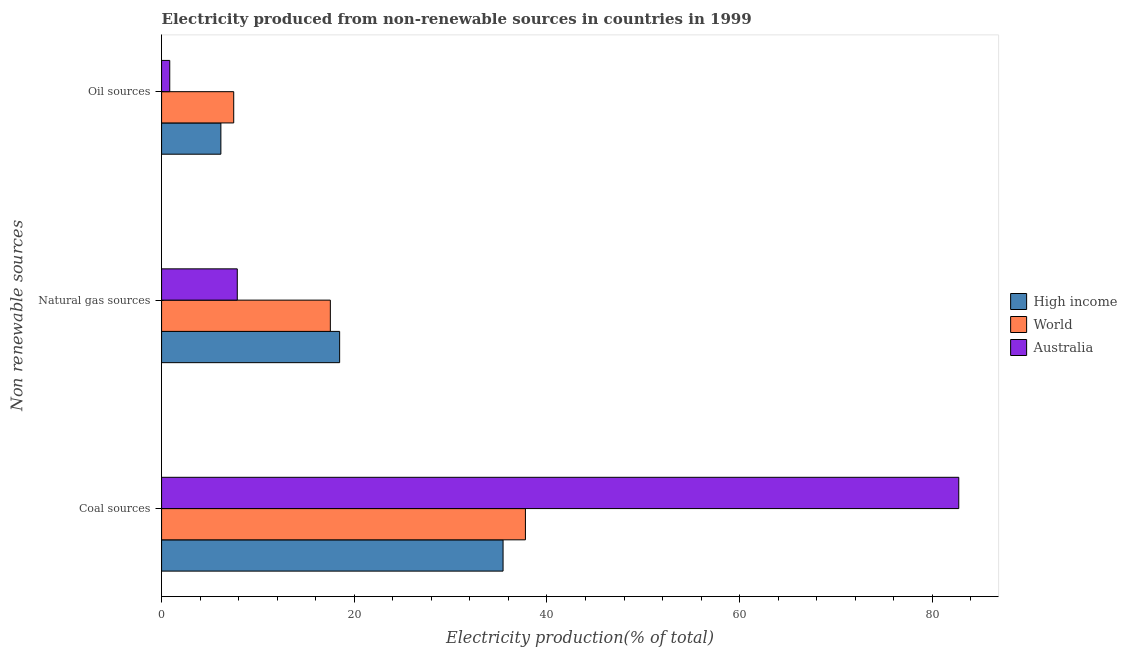Are the number of bars on each tick of the Y-axis equal?
Ensure brevity in your answer.  Yes. What is the label of the 2nd group of bars from the top?
Ensure brevity in your answer.  Natural gas sources. What is the percentage of electricity produced by oil sources in World?
Your answer should be very brief. 7.49. Across all countries, what is the maximum percentage of electricity produced by coal?
Provide a succinct answer. 82.75. Across all countries, what is the minimum percentage of electricity produced by oil sources?
Provide a succinct answer. 0.85. What is the total percentage of electricity produced by oil sources in the graph?
Your answer should be very brief. 14.49. What is the difference between the percentage of electricity produced by oil sources in High income and that in World?
Your answer should be compact. -1.33. What is the difference between the percentage of electricity produced by coal in Australia and the percentage of electricity produced by oil sources in World?
Your answer should be very brief. 75.26. What is the average percentage of electricity produced by coal per country?
Your answer should be compact. 51.99. What is the difference between the percentage of electricity produced by oil sources and percentage of electricity produced by coal in World?
Offer a terse response. -30.28. In how many countries, is the percentage of electricity produced by oil sources greater than 28 %?
Make the answer very short. 0. What is the ratio of the percentage of electricity produced by coal in Australia to that in High income?
Provide a succinct answer. 2.33. What is the difference between the highest and the second highest percentage of electricity produced by oil sources?
Keep it short and to the point. 1.33. What is the difference between the highest and the lowest percentage of electricity produced by coal?
Your answer should be very brief. 47.3. In how many countries, is the percentage of electricity produced by oil sources greater than the average percentage of electricity produced by oil sources taken over all countries?
Your response must be concise. 2. Is the sum of the percentage of electricity produced by natural gas in World and Australia greater than the maximum percentage of electricity produced by oil sources across all countries?
Ensure brevity in your answer.  Yes. Are all the bars in the graph horizontal?
Ensure brevity in your answer.  Yes. How many countries are there in the graph?
Provide a short and direct response. 3. What is the difference between two consecutive major ticks on the X-axis?
Your answer should be compact. 20. Where does the legend appear in the graph?
Provide a short and direct response. Center right. How many legend labels are there?
Give a very brief answer. 3. How are the legend labels stacked?
Provide a short and direct response. Vertical. What is the title of the graph?
Your answer should be very brief. Electricity produced from non-renewable sources in countries in 1999. What is the label or title of the Y-axis?
Provide a succinct answer. Non renewable sources. What is the Electricity production(% of total) of High income in Coal sources?
Keep it short and to the point. 35.45. What is the Electricity production(% of total) in World in Coal sources?
Make the answer very short. 37.77. What is the Electricity production(% of total) in Australia in Coal sources?
Give a very brief answer. 82.75. What is the Electricity production(% of total) in High income in Natural gas sources?
Provide a short and direct response. 18.48. What is the Electricity production(% of total) of World in Natural gas sources?
Keep it short and to the point. 17.52. What is the Electricity production(% of total) in Australia in Natural gas sources?
Provide a succinct answer. 7.86. What is the Electricity production(% of total) in High income in Oil sources?
Provide a short and direct response. 6.15. What is the Electricity production(% of total) in World in Oil sources?
Your answer should be very brief. 7.49. What is the Electricity production(% of total) in Australia in Oil sources?
Your answer should be very brief. 0.85. Across all Non renewable sources, what is the maximum Electricity production(% of total) in High income?
Provide a short and direct response. 35.45. Across all Non renewable sources, what is the maximum Electricity production(% of total) in World?
Make the answer very short. 37.77. Across all Non renewable sources, what is the maximum Electricity production(% of total) in Australia?
Your response must be concise. 82.75. Across all Non renewable sources, what is the minimum Electricity production(% of total) in High income?
Offer a very short reply. 6.15. Across all Non renewable sources, what is the minimum Electricity production(% of total) in World?
Keep it short and to the point. 7.49. Across all Non renewable sources, what is the minimum Electricity production(% of total) of Australia?
Offer a very short reply. 0.85. What is the total Electricity production(% of total) in High income in the graph?
Offer a very short reply. 60.09. What is the total Electricity production(% of total) in World in the graph?
Make the answer very short. 62.77. What is the total Electricity production(% of total) in Australia in the graph?
Offer a very short reply. 91.46. What is the difference between the Electricity production(% of total) in High income in Coal sources and that in Natural gas sources?
Provide a succinct answer. 16.96. What is the difference between the Electricity production(% of total) of World in Coal sources and that in Natural gas sources?
Make the answer very short. 20.25. What is the difference between the Electricity production(% of total) of Australia in Coal sources and that in Natural gas sources?
Your answer should be compact. 74.89. What is the difference between the Electricity production(% of total) in High income in Coal sources and that in Oil sources?
Provide a succinct answer. 29.29. What is the difference between the Electricity production(% of total) of World in Coal sources and that in Oil sources?
Provide a succinct answer. 30.28. What is the difference between the Electricity production(% of total) in Australia in Coal sources and that in Oil sources?
Your answer should be compact. 81.9. What is the difference between the Electricity production(% of total) of High income in Natural gas sources and that in Oil sources?
Offer a terse response. 12.33. What is the difference between the Electricity production(% of total) of World in Natural gas sources and that in Oil sources?
Your response must be concise. 10.03. What is the difference between the Electricity production(% of total) in Australia in Natural gas sources and that in Oil sources?
Keep it short and to the point. 7.01. What is the difference between the Electricity production(% of total) of High income in Coal sources and the Electricity production(% of total) of World in Natural gas sources?
Keep it short and to the point. 17.93. What is the difference between the Electricity production(% of total) of High income in Coal sources and the Electricity production(% of total) of Australia in Natural gas sources?
Provide a short and direct response. 27.59. What is the difference between the Electricity production(% of total) of World in Coal sources and the Electricity production(% of total) of Australia in Natural gas sources?
Offer a very short reply. 29.91. What is the difference between the Electricity production(% of total) in High income in Coal sources and the Electricity production(% of total) in World in Oil sources?
Provide a succinct answer. 27.96. What is the difference between the Electricity production(% of total) of High income in Coal sources and the Electricity production(% of total) of Australia in Oil sources?
Give a very brief answer. 34.6. What is the difference between the Electricity production(% of total) of World in Coal sources and the Electricity production(% of total) of Australia in Oil sources?
Provide a short and direct response. 36.92. What is the difference between the Electricity production(% of total) of High income in Natural gas sources and the Electricity production(% of total) of World in Oil sources?
Give a very brief answer. 11. What is the difference between the Electricity production(% of total) in High income in Natural gas sources and the Electricity production(% of total) in Australia in Oil sources?
Offer a very short reply. 17.63. What is the difference between the Electricity production(% of total) of World in Natural gas sources and the Electricity production(% of total) of Australia in Oil sources?
Your response must be concise. 16.67. What is the average Electricity production(% of total) in High income per Non renewable sources?
Your answer should be very brief. 20.03. What is the average Electricity production(% of total) in World per Non renewable sources?
Your response must be concise. 20.92. What is the average Electricity production(% of total) of Australia per Non renewable sources?
Keep it short and to the point. 30.49. What is the difference between the Electricity production(% of total) of High income and Electricity production(% of total) of World in Coal sources?
Provide a short and direct response. -2.32. What is the difference between the Electricity production(% of total) in High income and Electricity production(% of total) in Australia in Coal sources?
Provide a succinct answer. -47.3. What is the difference between the Electricity production(% of total) in World and Electricity production(% of total) in Australia in Coal sources?
Your answer should be compact. -44.98. What is the difference between the Electricity production(% of total) in High income and Electricity production(% of total) in World in Natural gas sources?
Give a very brief answer. 0.97. What is the difference between the Electricity production(% of total) of High income and Electricity production(% of total) of Australia in Natural gas sources?
Your answer should be compact. 10.63. What is the difference between the Electricity production(% of total) in World and Electricity production(% of total) in Australia in Natural gas sources?
Provide a short and direct response. 9.66. What is the difference between the Electricity production(% of total) in High income and Electricity production(% of total) in World in Oil sources?
Give a very brief answer. -1.33. What is the difference between the Electricity production(% of total) in High income and Electricity production(% of total) in Australia in Oil sources?
Your answer should be very brief. 5.31. What is the difference between the Electricity production(% of total) in World and Electricity production(% of total) in Australia in Oil sources?
Your answer should be very brief. 6.64. What is the ratio of the Electricity production(% of total) of High income in Coal sources to that in Natural gas sources?
Keep it short and to the point. 1.92. What is the ratio of the Electricity production(% of total) of World in Coal sources to that in Natural gas sources?
Offer a very short reply. 2.16. What is the ratio of the Electricity production(% of total) of Australia in Coal sources to that in Natural gas sources?
Give a very brief answer. 10.53. What is the ratio of the Electricity production(% of total) in High income in Coal sources to that in Oil sources?
Your response must be concise. 5.76. What is the ratio of the Electricity production(% of total) in World in Coal sources to that in Oil sources?
Ensure brevity in your answer.  5.04. What is the ratio of the Electricity production(% of total) in Australia in Coal sources to that in Oil sources?
Offer a terse response. 97.45. What is the ratio of the Electricity production(% of total) in High income in Natural gas sources to that in Oil sources?
Keep it short and to the point. 3. What is the ratio of the Electricity production(% of total) in World in Natural gas sources to that in Oil sources?
Ensure brevity in your answer.  2.34. What is the ratio of the Electricity production(% of total) of Australia in Natural gas sources to that in Oil sources?
Provide a succinct answer. 9.25. What is the difference between the highest and the second highest Electricity production(% of total) of High income?
Your answer should be very brief. 16.96. What is the difference between the highest and the second highest Electricity production(% of total) of World?
Your response must be concise. 20.25. What is the difference between the highest and the second highest Electricity production(% of total) of Australia?
Offer a terse response. 74.89. What is the difference between the highest and the lowest Electricity production(% of total) in High income?
Your answer should be compact. 29.29. What is the difference between the highest and the lowest Electricity production(% of total) of World?
Keep it short and to the point. 30.28. What is the difference between the highest and the lowest Electricity production(% of total) of Australia?
Keep it short and to the point. 81.9. 